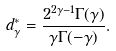<formula> <loc_0><loc_0><loc_500><loc_500>d _ { \gamma } ^ { * } = \frac { 2 ^ { 2 \gamma - 1 } \Gamma ( \gamma ) } { \gamma \Gamma ( - \gamma ) } .</formula> 